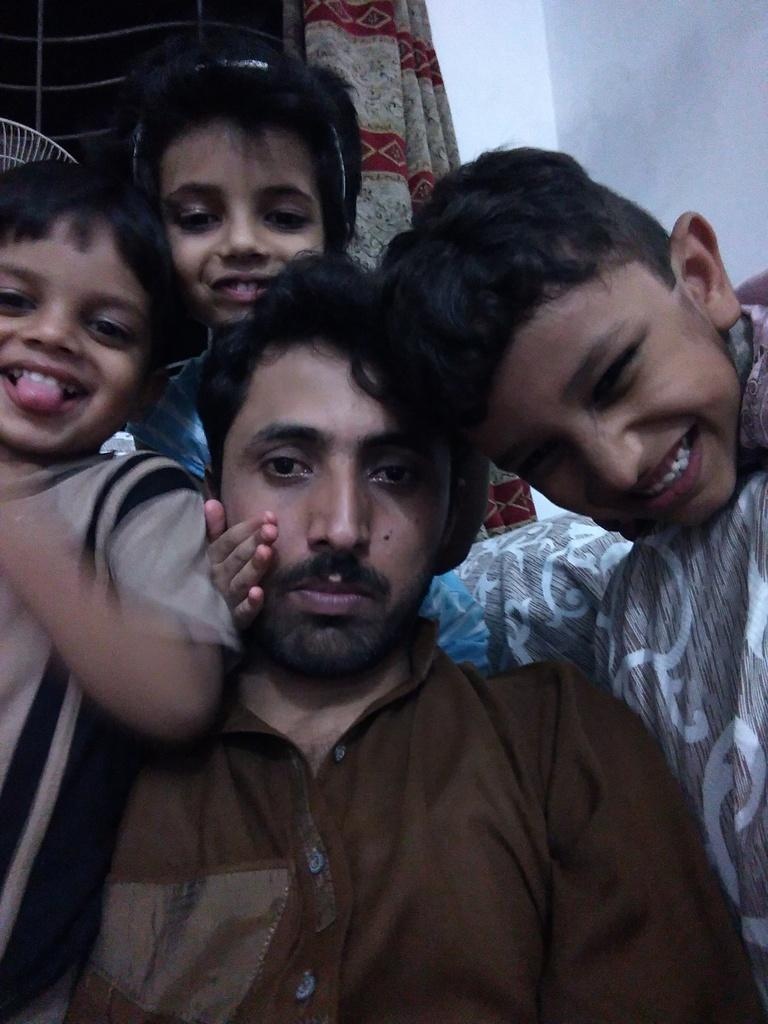How many people are present in the image? There are four persons in the image. What can be seen in the background of the image? There is a window in the background of the image. Are there any window treatments visible in the image? Yes, window curtains are attached to the window. What type of pickle is being passed around by the father in the image? There is no father or pickle present in the image. What sound can be heard coming from the persons in the image? The image is static, so no sound can be heard. 